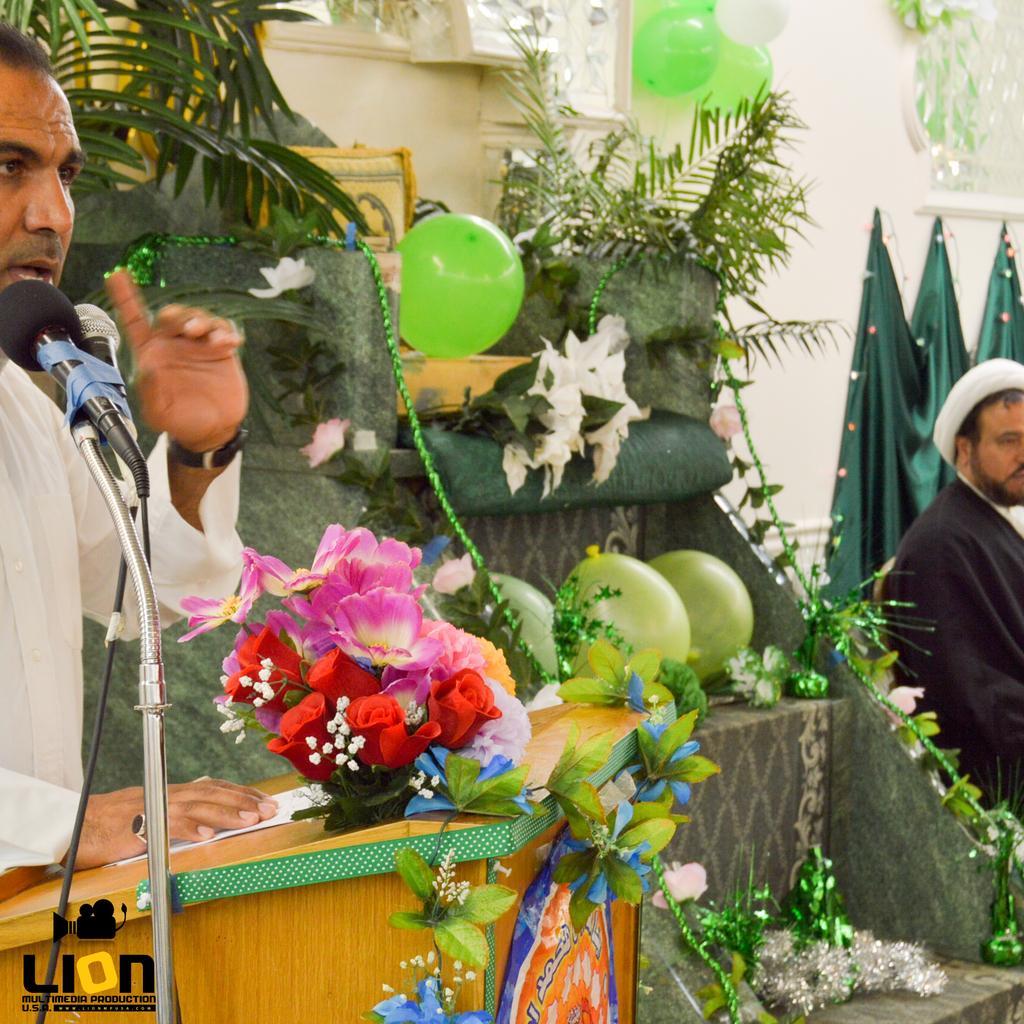Can you describe this image briefly? In this image, we can see balloons, decors and plants on steps. There are some flowers on the podium. There is a person in front of mics wearing clothes. There is an another person on the right side of the image. There is a cloth on the wall. 